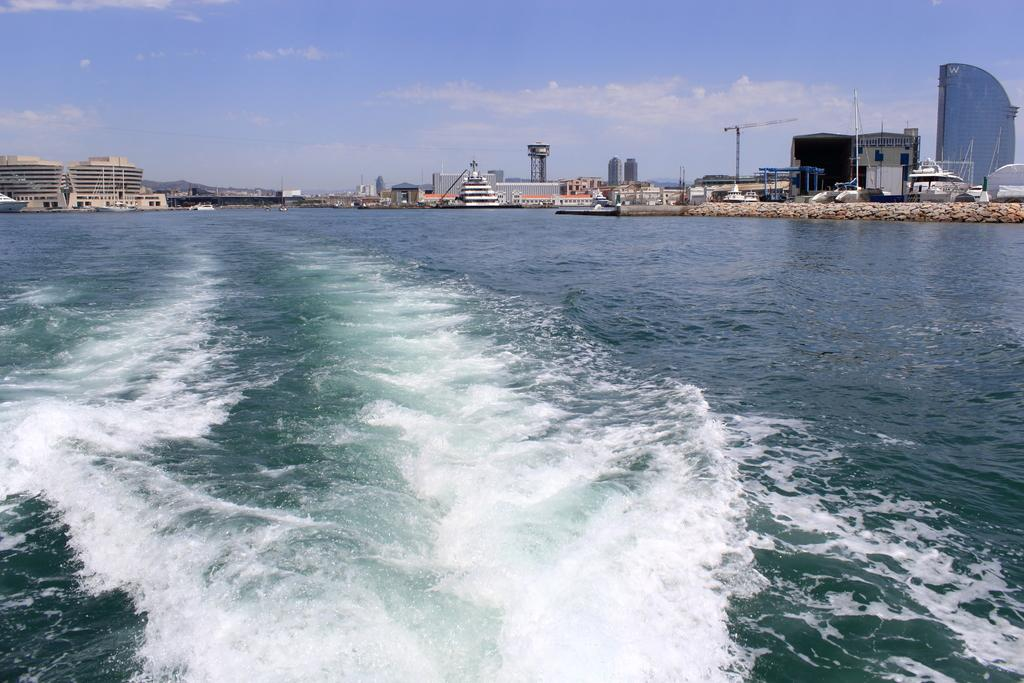What type of natural environment can be seen in the image? There is sea visible in the image. What else is visible in the image besides the sea? The sky is visible in the image, along with clouds, construction cranes, buildings, pillars, and rocks. Can you describe the sky in the image? The sky is visible in the image, and clouds are present. What type of structures can be seen in the image? Buildings and construction cranes are visible in the image. What other features can be seen in the image? Pillars and rocks are visible in the image. What type of suit is the porter wearing in the image? There is no porter present in the image, and therefore no suit can be observed. What is the head of the person in the image doing? There is no person present in the image, and therefore no head can be observed. 